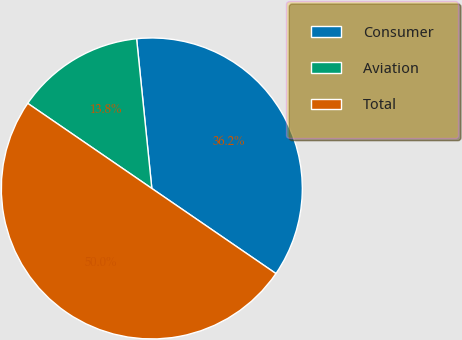<chart> <loc_0><loc_0><loc_500><loc_500><pie_chart><fcel>Consumer<fcel>Aviation<fcel>Total<nl><fcel>36.18%<fcel>13.82%<fcel>50.0%<nl></chart> 